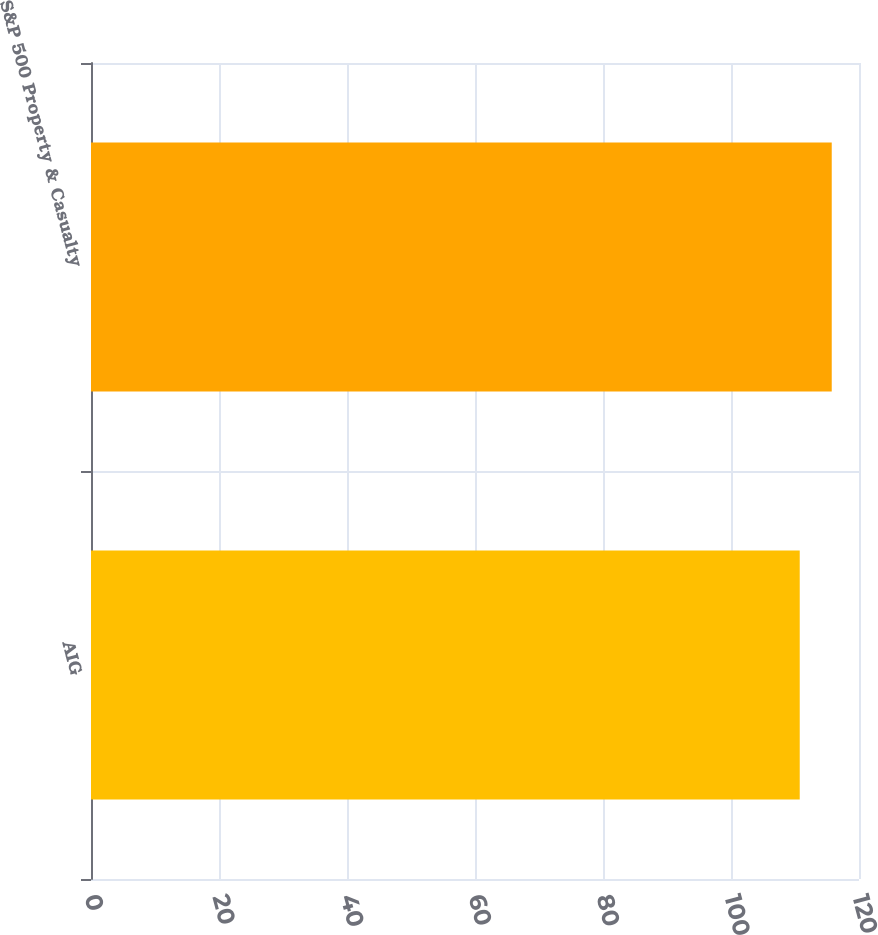Convert chart to OTSL. <chart><loc_0><loc_0><loc_500><loc_500><bar_chart><fcel>AIG<fcel>S&P 500 Property & Casualty<nl><fcel>110.74<fcel>115.74<nl></chart> 